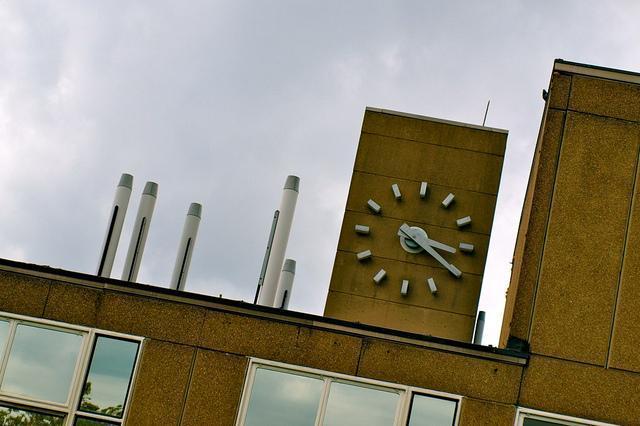How many birds are on the wall?
Give a very brief answer. 0. How many clocks can be seen?
Give a very brief answer. 1. How many clocks are in the image?
Give a very brief answer. 1. 